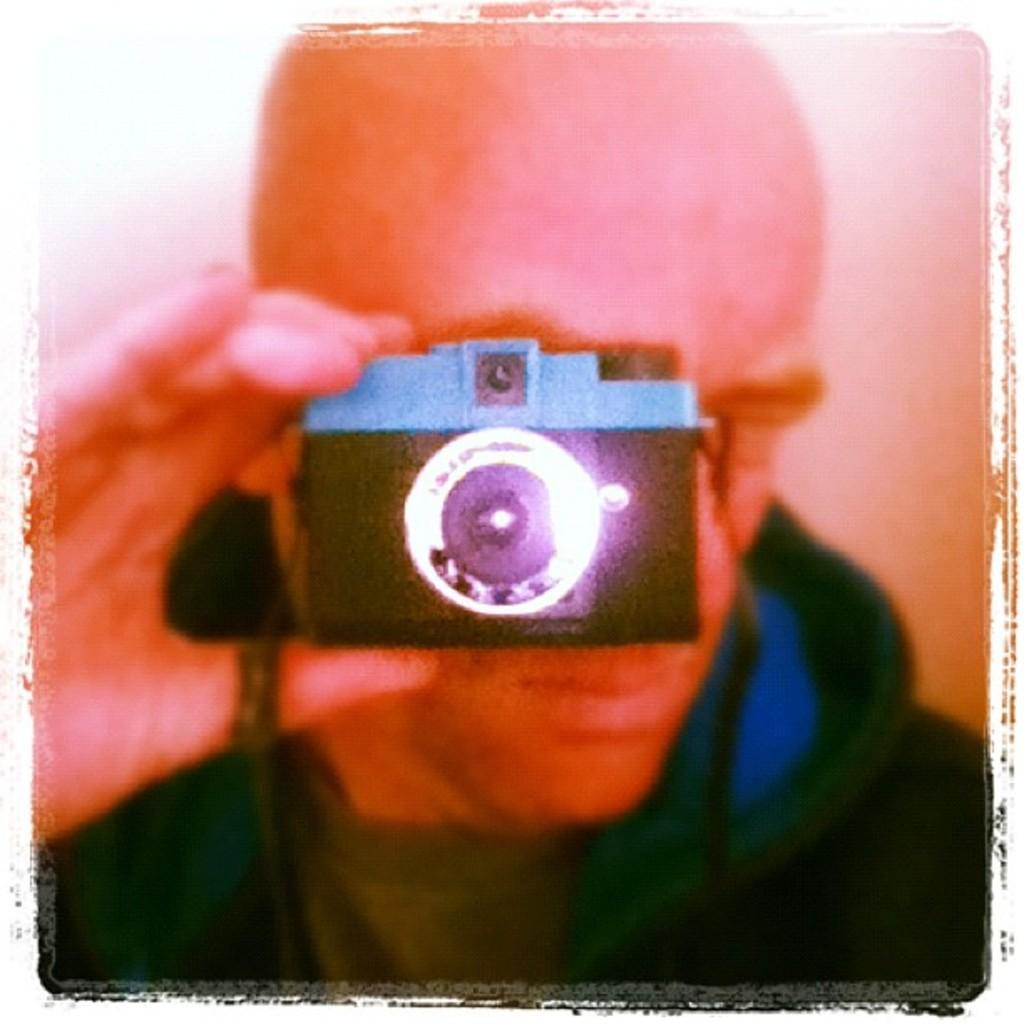What is the main subject of the image? There is a person in the image. What is the person holding in the image? The person is holding a camera. What type of list is the person writing in the image? There is no list or writing present in the image; the person is holding a camera. 